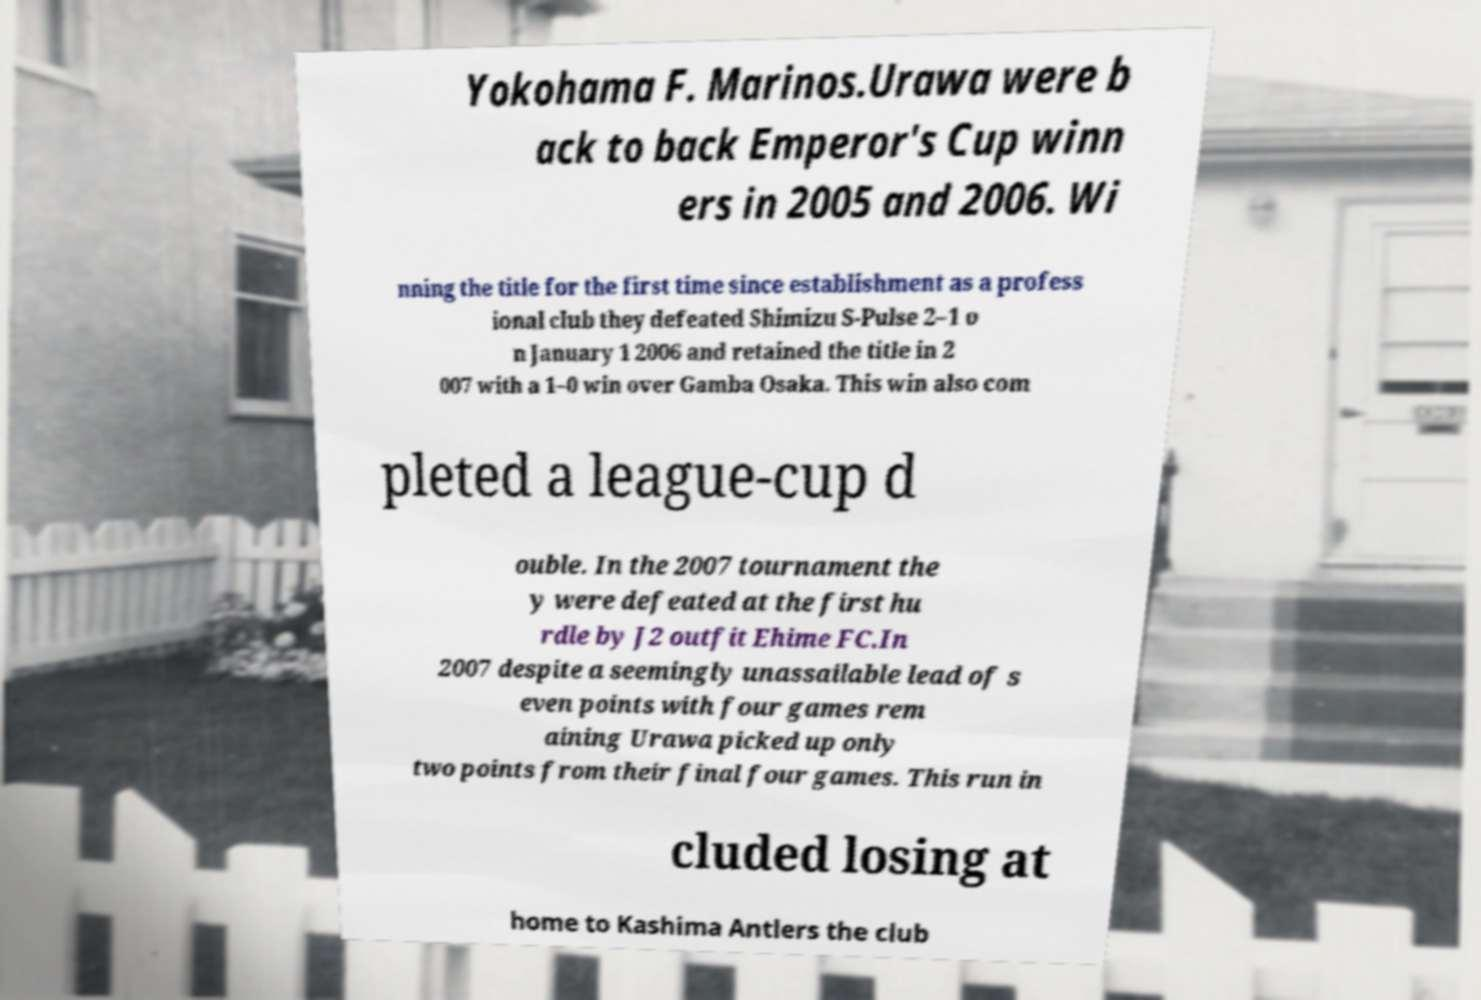Please read and relay the text visible in this image. What does it say? Yokohama F. Marinos.Urawa were b ack to back Emperor's Cup winn ers in 2005 and 2006. Wi nning the title for the first time since establishment as a profess ional club they defeated Shimizu S-Pulse 2–1 o n January 1 2006 and retained the title in 2 007 with a 1–0 win over Gamba Osaka. This win also com pleted a league-cup d ouble. In the 2007 tournament the y were defeated at the first hu rdle by J2 outfit Ehime FC.In 2007 despite a seemingly unassailable lead of s even points with four games rem aining Urawa picked up only two points from their final four games. This run in cluded losing at home to Kashima Antlers the club 